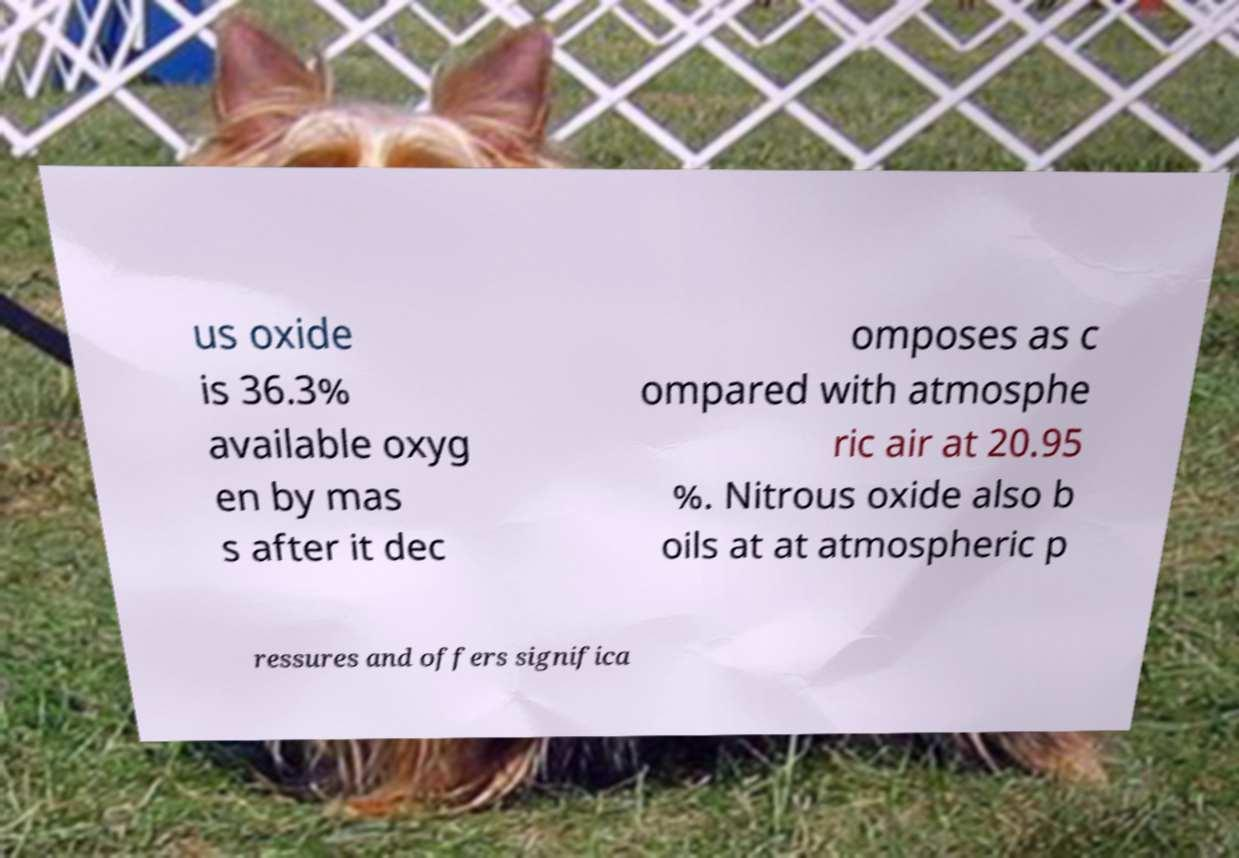Please read and relay the text visible in this image. What does it say? us oxide is 36.3% available oxyg en by mas s after it dec omposes as c ompared with atmosphe ric air at 20.95 %. Nitrous oxide also b oils at at atmospheric p ressures and offers significa 